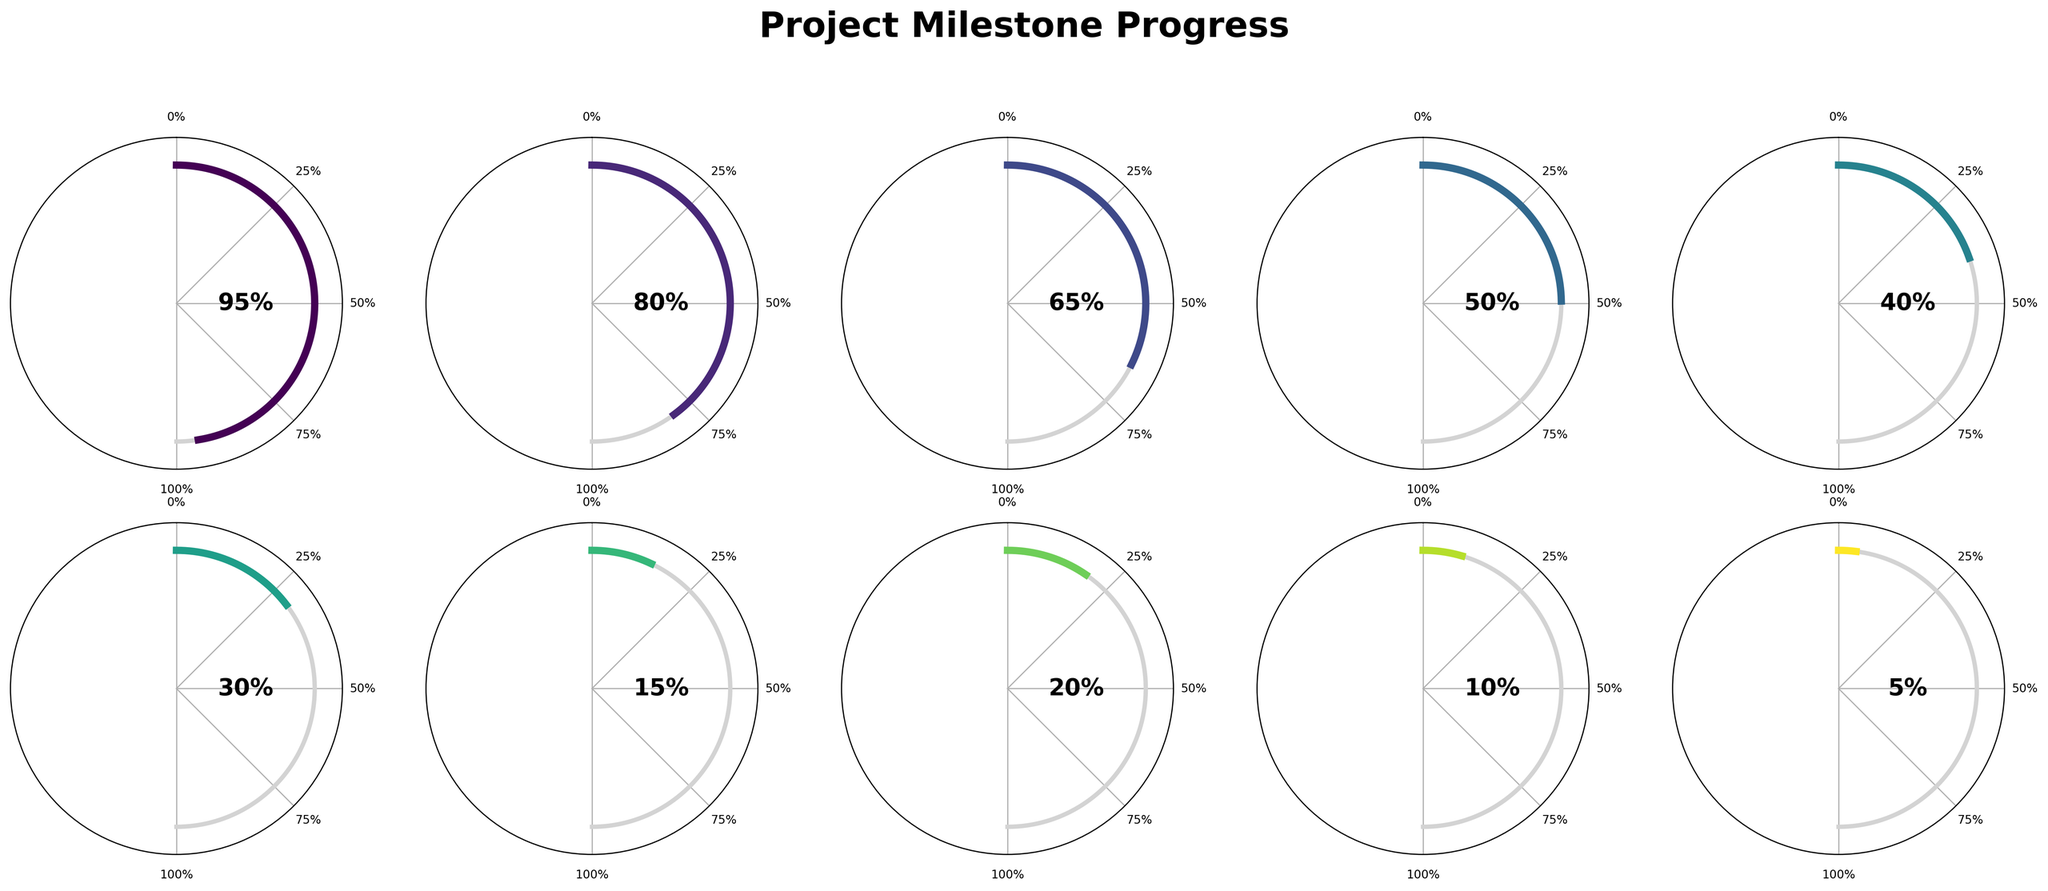What's the title of the figure? The title of the figure is displayed prominently at the top center in large, bold font.
Answer: Project Milestone Progress How many milestones are being tracked in the figure? The figure uses a 2x5 grid layout, which visually represents 10 distinct development milestones.
Answer: 10 Which milestone has the highest completion percentage? By examining the gauge charts, the milestone with the needle closest to 100% is "Requirements Gathering".
Answer: Requirements Gathering What is the average completion percentage across all milestones? Add all the completion percentages: (95 + 80 + 65 + 50 + 40 + 30 + 15 + 20 + 10 + 5) = 410, then divide by the number of milestones, 410/10 = 41.
Answer: 41% What is the percentage difference between "API Development" and "Integration Testing"? "API Development" has a completion percentage of 65%, and "Integration Testing" has 15%. The difference is 65 - 15 = 50.
Answer: 50% Which milestones are less than 25% complete? Evaluate each gauge chart and identify milestones with needles pointing to less than 25%, which are: "Integration Testing", "Documentation", "Performance Optimization", and "Deployment Preparation".
Answer: Integration Testing, Documentation, Performance Optimization, Deployment Preparation Comparing "Database Design" and "User Interface Implementation", which phase has a higher completion percentage? "Database Design" has a completion percentage of 80%, while "User Interface Implementation" has 50%. Therefore, "Database Design" is higher.
Answer: Database Design What's the difference in completion percentage between the most and least advanced milestones? The most advanced milestone is "Requirements Gathering" at 95%, and the least advanced is "Deployment Preparation" at 5%. The difference is 95 - 5 = 90.
Answer: 90% If the goal is to bring every milestone up to at least 50% completion, how many milestones need more effort? Identify the milestones below 50%: "Algorithm Integration" (40%), "Unit Testing" (30%), "Integration Testing" (15%), "Documentation" (20%), "Performance Optimization" (10%), and "Deployment Preparation" (5%); there are 6 milestones in total.
Answer: 6 